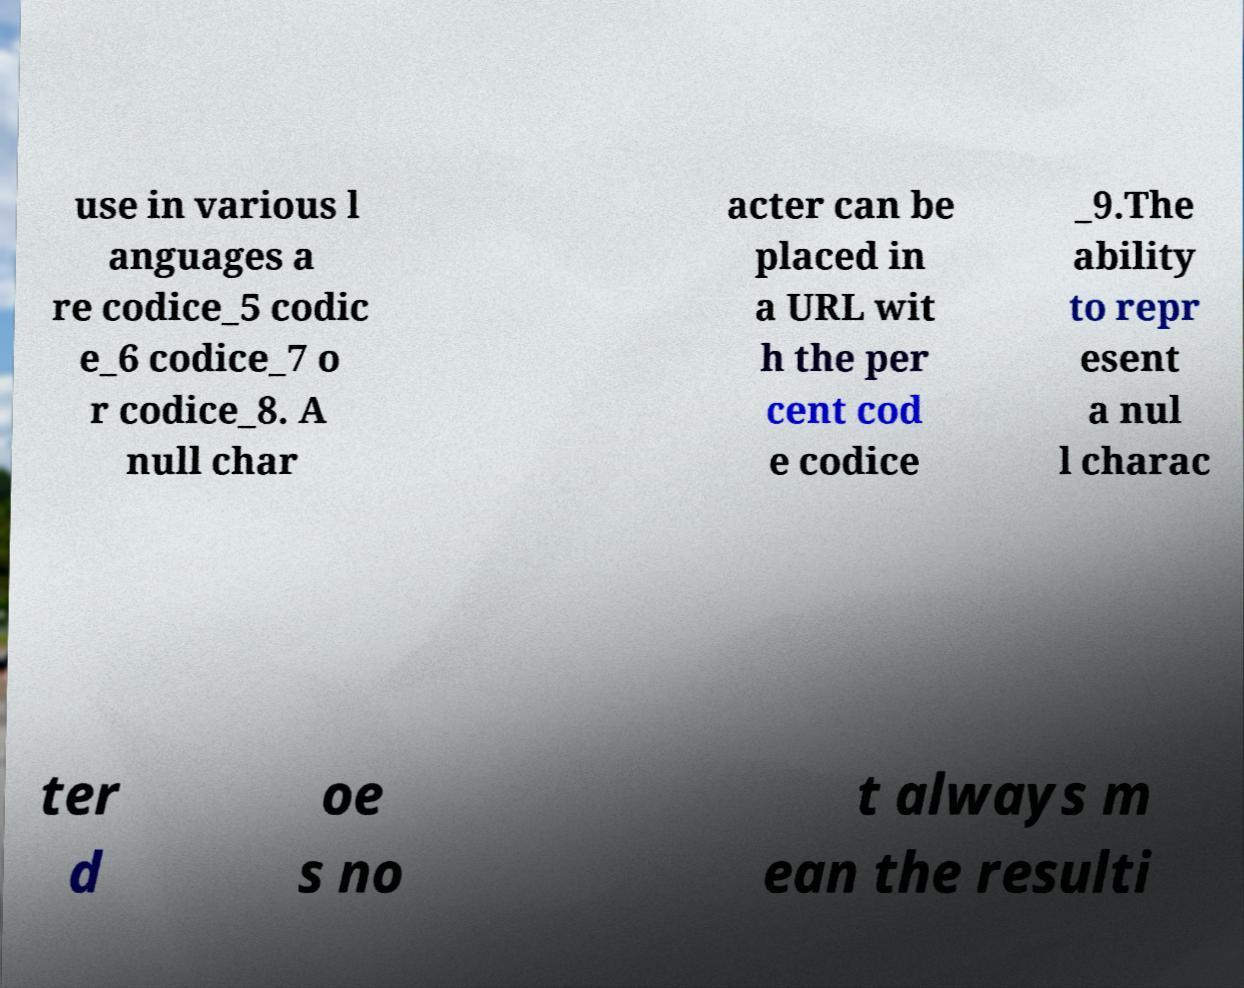Could you assist in decoding the text presented in this image and type it out clearly? use in various l anguages a re codice_5 codic e_6 codice_7 o r codice_8. A null char acter can be placed in a URL wit h the per cent cod e codice _9.The ability to repr esent a nul l charac ter d oe s no t always m ean the resulti 